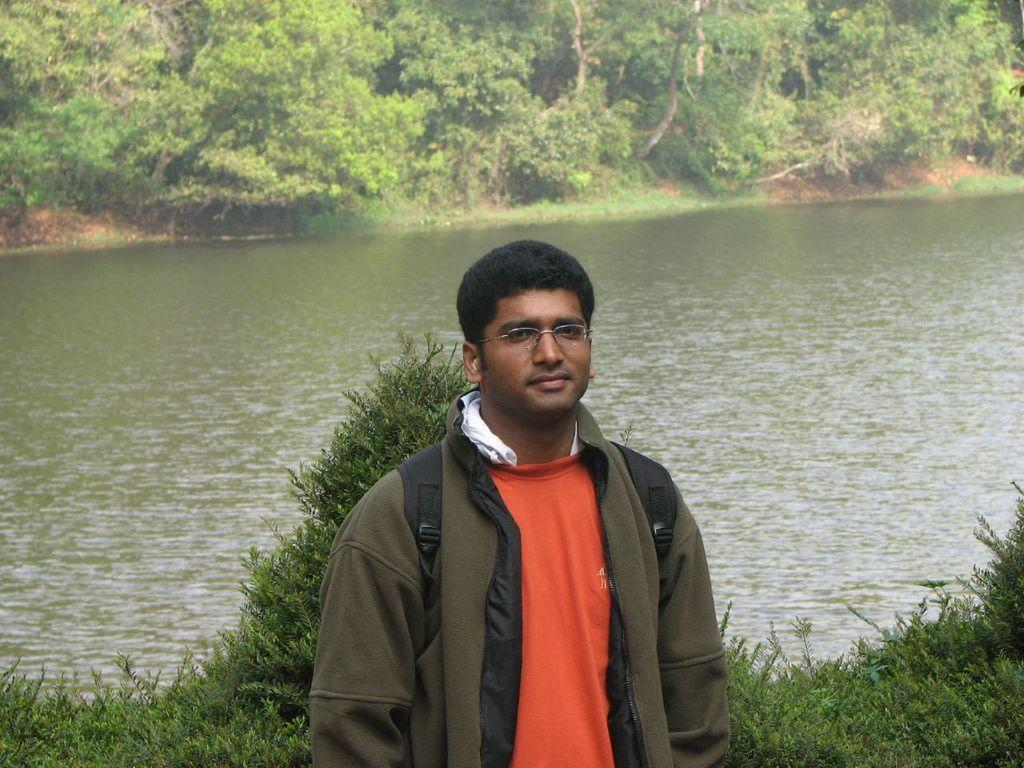Who is present in the image? There is a man in the image. What is the man wearing? The man is wearing a jacket. Where is the man located in the image? The man is standing at the bank of a river. What can be seen around the river in the image? The river is surrounded by trees. What type of clouds can be seen in the image? There are no clouds visible in the image; it features a man standing at the bank of a river surrounded by trees. 